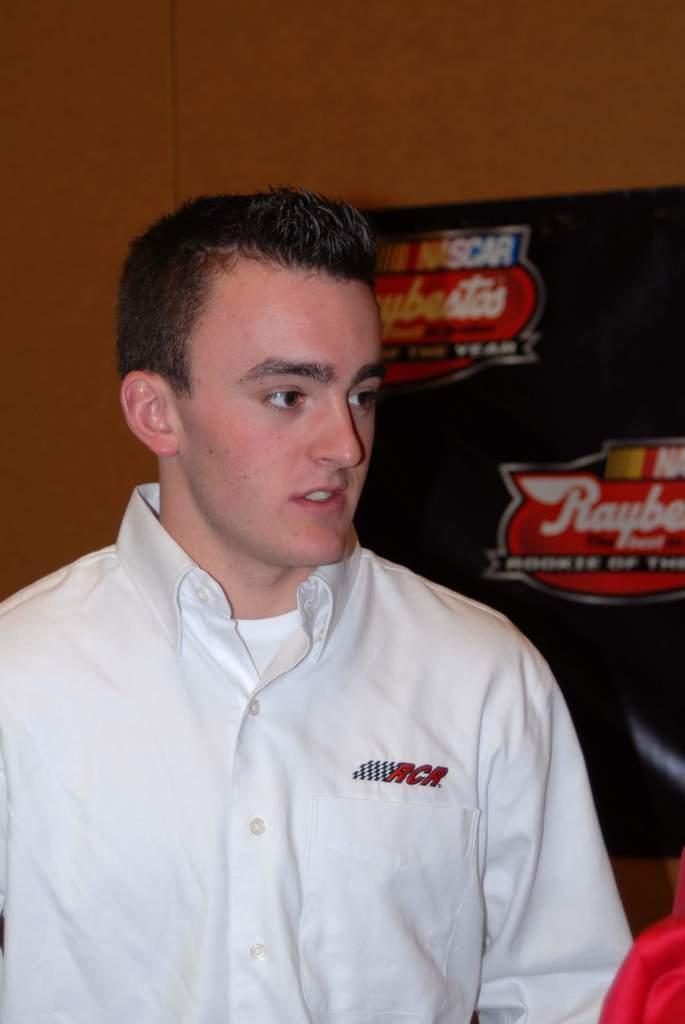<image>
Provide a brief description of the given image. Young man standing in front of a board that has Nascar on it. 